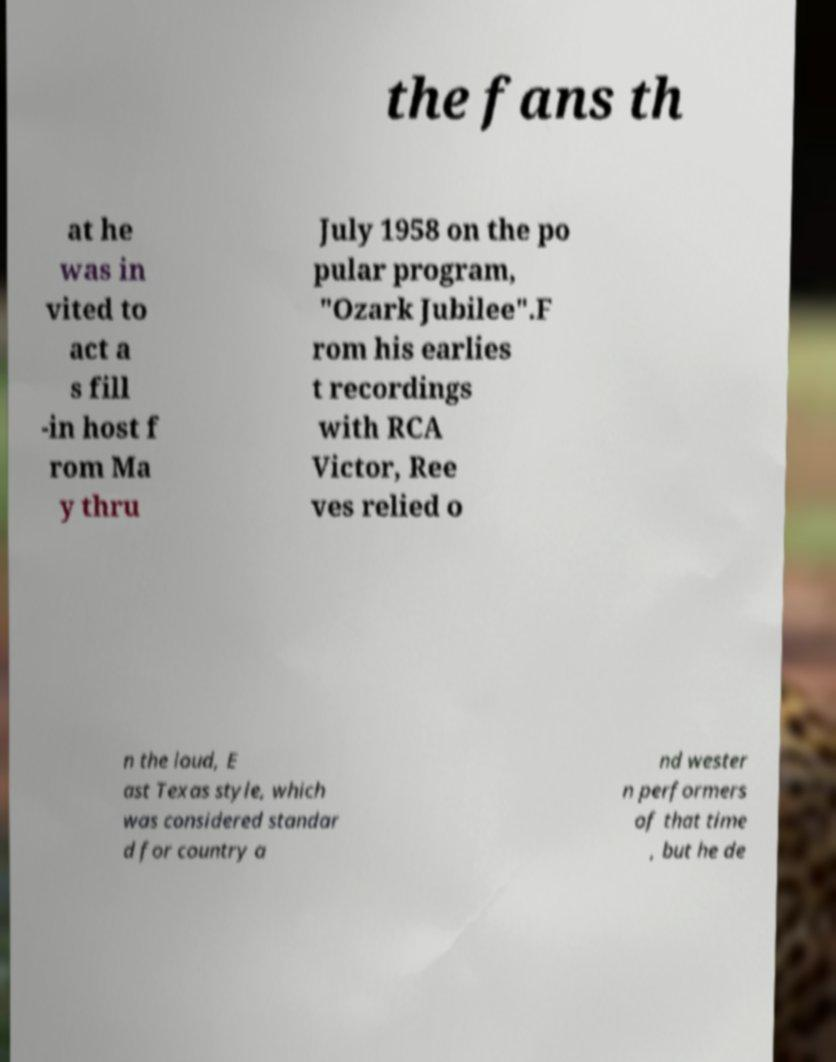For documentation purposes, I need the text within this image transcribed. Could you provide that? the fans th at he was in vited to act a s fill -in host f rom Ma y thru July 1958 on the po pular program, "Ozark Jubilee".F rom his earlies t recordings with RCA Victor, Ree ves relied o n the loud, E ast Texas style, which was considered standar d for country a nd wester n performers of that time , but he de 